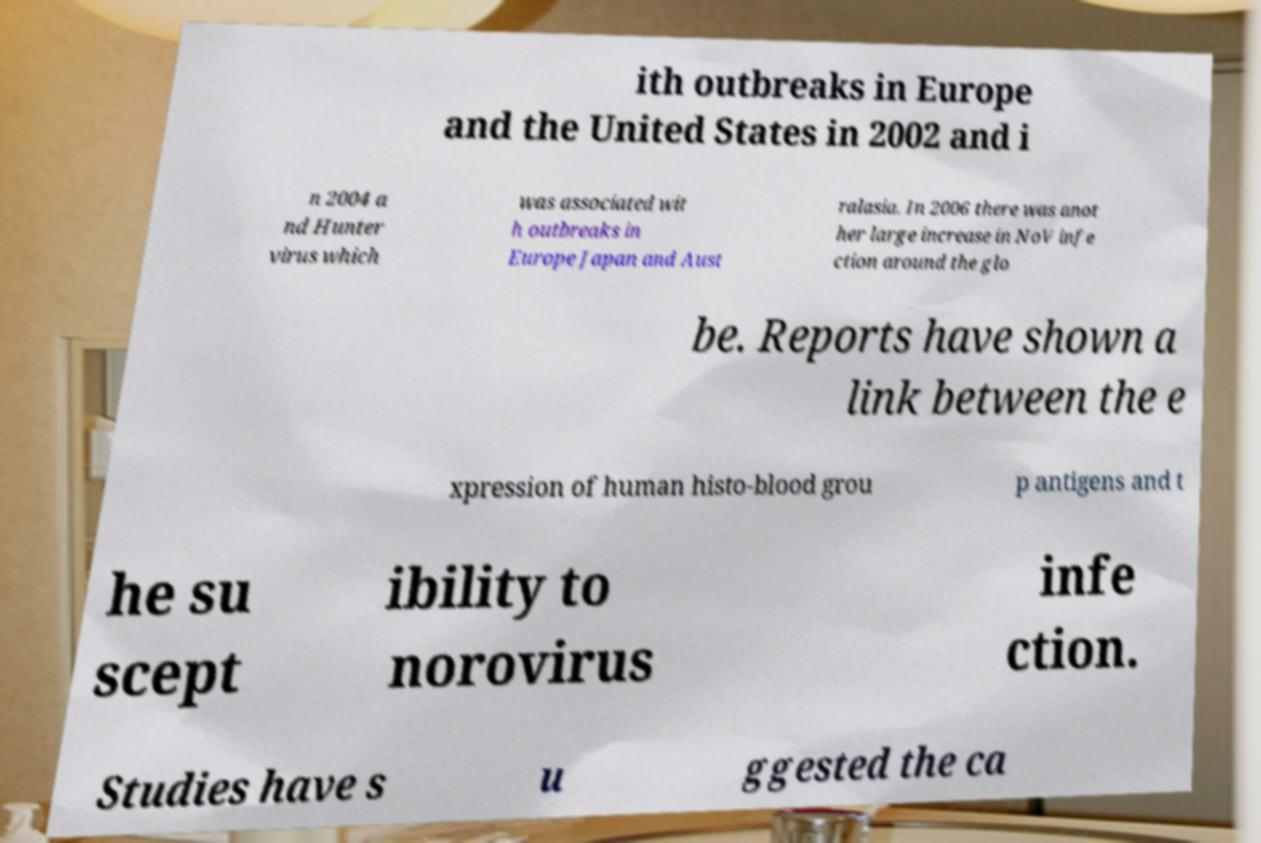I need the written content from this picture converted into text. Can you do that? ith outbreaks in Europe and the United States in 2002 and i n 2004 a nd Hunter virus which was associated wit h outbreaks in Europe Japan and Aust ralasia. In 2006 there was anot her large increase in NoV infe ction around the glo be. Reports have shown a link between the e xpression of human histo-blood grou p antigens and t he su scept ibility to norovirus infe ction. Studies have s u ggested the ca 